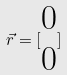Convert formula to latex. <formula><loc_0><loc_0><loc_500><loc_500>\vec { r } = [ \begin{matrix} 0 \\ 0 \end{matrix} ]</formula> 